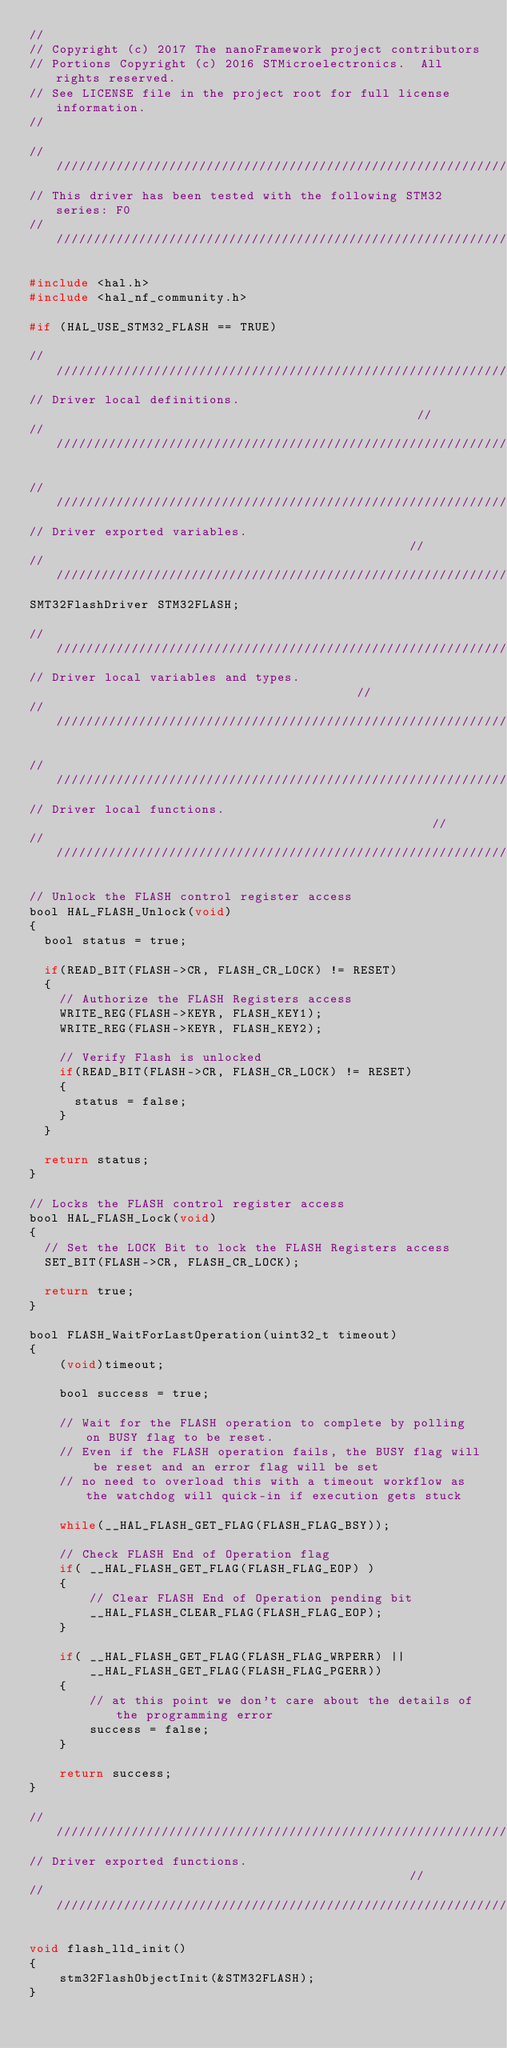Convert code to text. <code><loc_0><loc_0><loc_500><loc_500><_C_>//
// Copyright (c) 2017 The nanoFramework project contributors
// Portions Copyright (c) 2016 STMicroelectronics.  All rights reserved.
// See LICENSE file in the project root for full license information.
//

///////////////////////////////////////////////////////////////////////////////
// This driver has been tested with the following STM32 series: F0
///////////////////////////////////////////////////////////////////////////////

#include <hal.h>
#include <hal_nf_community.h>

#if (HAL_USE_STM32_FLASH == TRUE)

///////////////////////////////////////////////////////////////////////////////
// Driver local definitions.                                                 //
///////////////////////////////////////////////////////////////////////////////

///////////////////////////////////////////////////////////////////////////////
// Driver exported variables.                                                //
///////////////////////////////////////////////////////////////////////////////
SMT32FlashDriver STM32FLASH;

///////////////////////////////////////////////////////////////////////////////
// Driver local variables and types.                                         //
///////////////////////////////////////////////////////////////////////////////

///////////////////////////////////////////////////////////////////////////////
// Driver local functions.                                                   //
///////////////////////////////////////////////////////////////////////////////

// Unlock the FLASH control register access
bool HAL_FLASH_Unlock(void)
{
  bool status = true;

  if(READ_BIT(FLASH->CR, FLASH_CR_LOCK) != RESET)
  {
    // Authorize the FLASH Registers access
    WRITE_REG(FLASH->KEYR, FLASH_KEY1);
    WRITE_REG(FLASH->KEYR, FLASH_KEY2);

    // Verify Flash is unlocked
    if(READ_BIT(FLASH->CR, FLASH_CR_LOCK) != RESET)
    {
      status = false;
    }
  }

  return status; 
}

// Locks the FLASH control register access
bool HAL_FLASH_Lock(void)
{
  // Set the LOCK Bit to lock the FLASH Registers access
  SET_BIT(FLASH->CR, FLASH_CR_LOCK);
  
  return true;  
}

bool FLASH_WaitForLastOperation(uint32_t timeout)
{
    (void)timeout;

    bool success = true;
 
    // Wait for the FLASH operation to complete by polling on BUSY flag to be reset.
    // Even if the FLASH operation fails, the BUSY flag will be reset and an error flag will be set
    // no need to overload this with a timeout workflow as the watchdog will quick-in if execution gets stuck

    while(__HAL_FLASH_GET_FLAG(FLASH_FLAG_BSY));
        
    // Check FLASH End of Operation flag 
    if( __HAL_FLASH_GET_FLAG(FLASH_FLAG_EOP) )
    {
        // Clear FLASH End of Operation pending bit
        __HAL_FLASH_CLEAR_FLAG(FLASH_FLAG_EOP);
    }

    if( __HAL_FLASH_GET_FLAG(FLASH_FLAG_WRPERR) ||
        __HAL_FLASH_GET_FLAG(FLASH_FLAG_PGERR))
    {
        // at this point we don't care about the details of the programming error
        success = false;
    }

    return success;
}

///////////////////////////////////////////////////////////////////////////////
// Driver exported functions.                                                //
///////////////////////////////////////////////////////////////////////////////

void flash_lld_init()
{
    stm32FlashObjectInit(&STM32FLASH);
}
</code> 